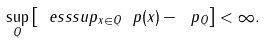<formula> <loc_0><loc_0><loc_500><loc_500>\sup _ { Q } \left [ \ e s s s u p _ { x \in Q } \ p ( x ) - \ p _ { Q } \right ] < \infty .</formula> 